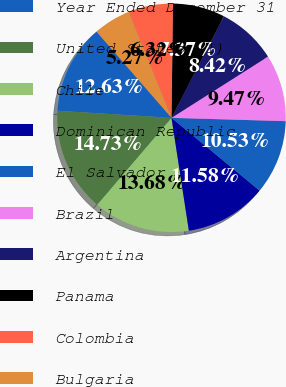Convert chart. <chart><loc_0><loc_0><loc_500><loc_500><pie_chart><fcel>Year Ended December 31<fcel>United States (1)<fcel>Chile<fcel>Dominican Republic<fcel>El Salvador<fcel>Brazil<fcel>Argentina<fcel>Panama<fcel>Colombia<fcel>Bulgaria<nl><fcel>12.63%<fcel>14.73%<fcel>13.68%<fcel>11.58%<fcel>10.53%<fcel>9.47%<fcel>8.42%<fcel>7.37%<fcel>6.32%<fcel>5.27%<nl></chart> 